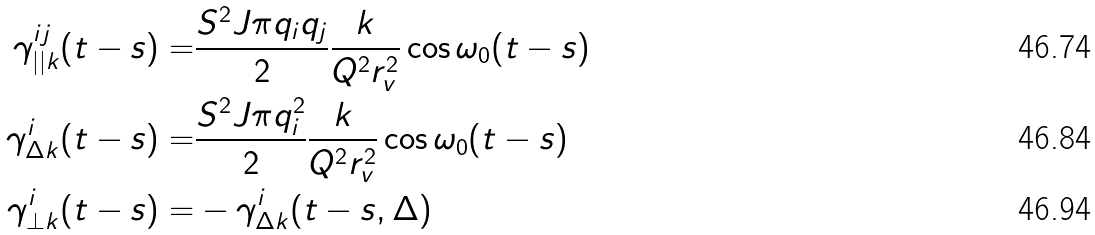Convert formula to latex. <formula><loc_0><loc_0><loc_500><loc_500>\gamma _ { | | k } ^ { i j } ( t - s ) = & \frac { S ^ { 2 } J \pi q _ { i } q _ { j } } { 2 } \frac { k } { Q ^ { 2 } r _ { v } ^ { 2 } } \cos \omega _ { 0 } ( t - s ) \\ \gamma _ { \Delta k } ^ { i } ( t - s ) = & \frac { S ^ { 2 } J \pi q _ { i } ^ { 2 } } { 2 } \frac { k } { Q ^ { 2 } r _ { v } ^ { 2 } } \cos \omega _ { 0 } ( t - s ) \\ \gamma _ { \bot k } ^ { i } ( t - s ) = & - \gamma _ { \Delta k } ^ { i } ( t - s , \Delta )</formula> 